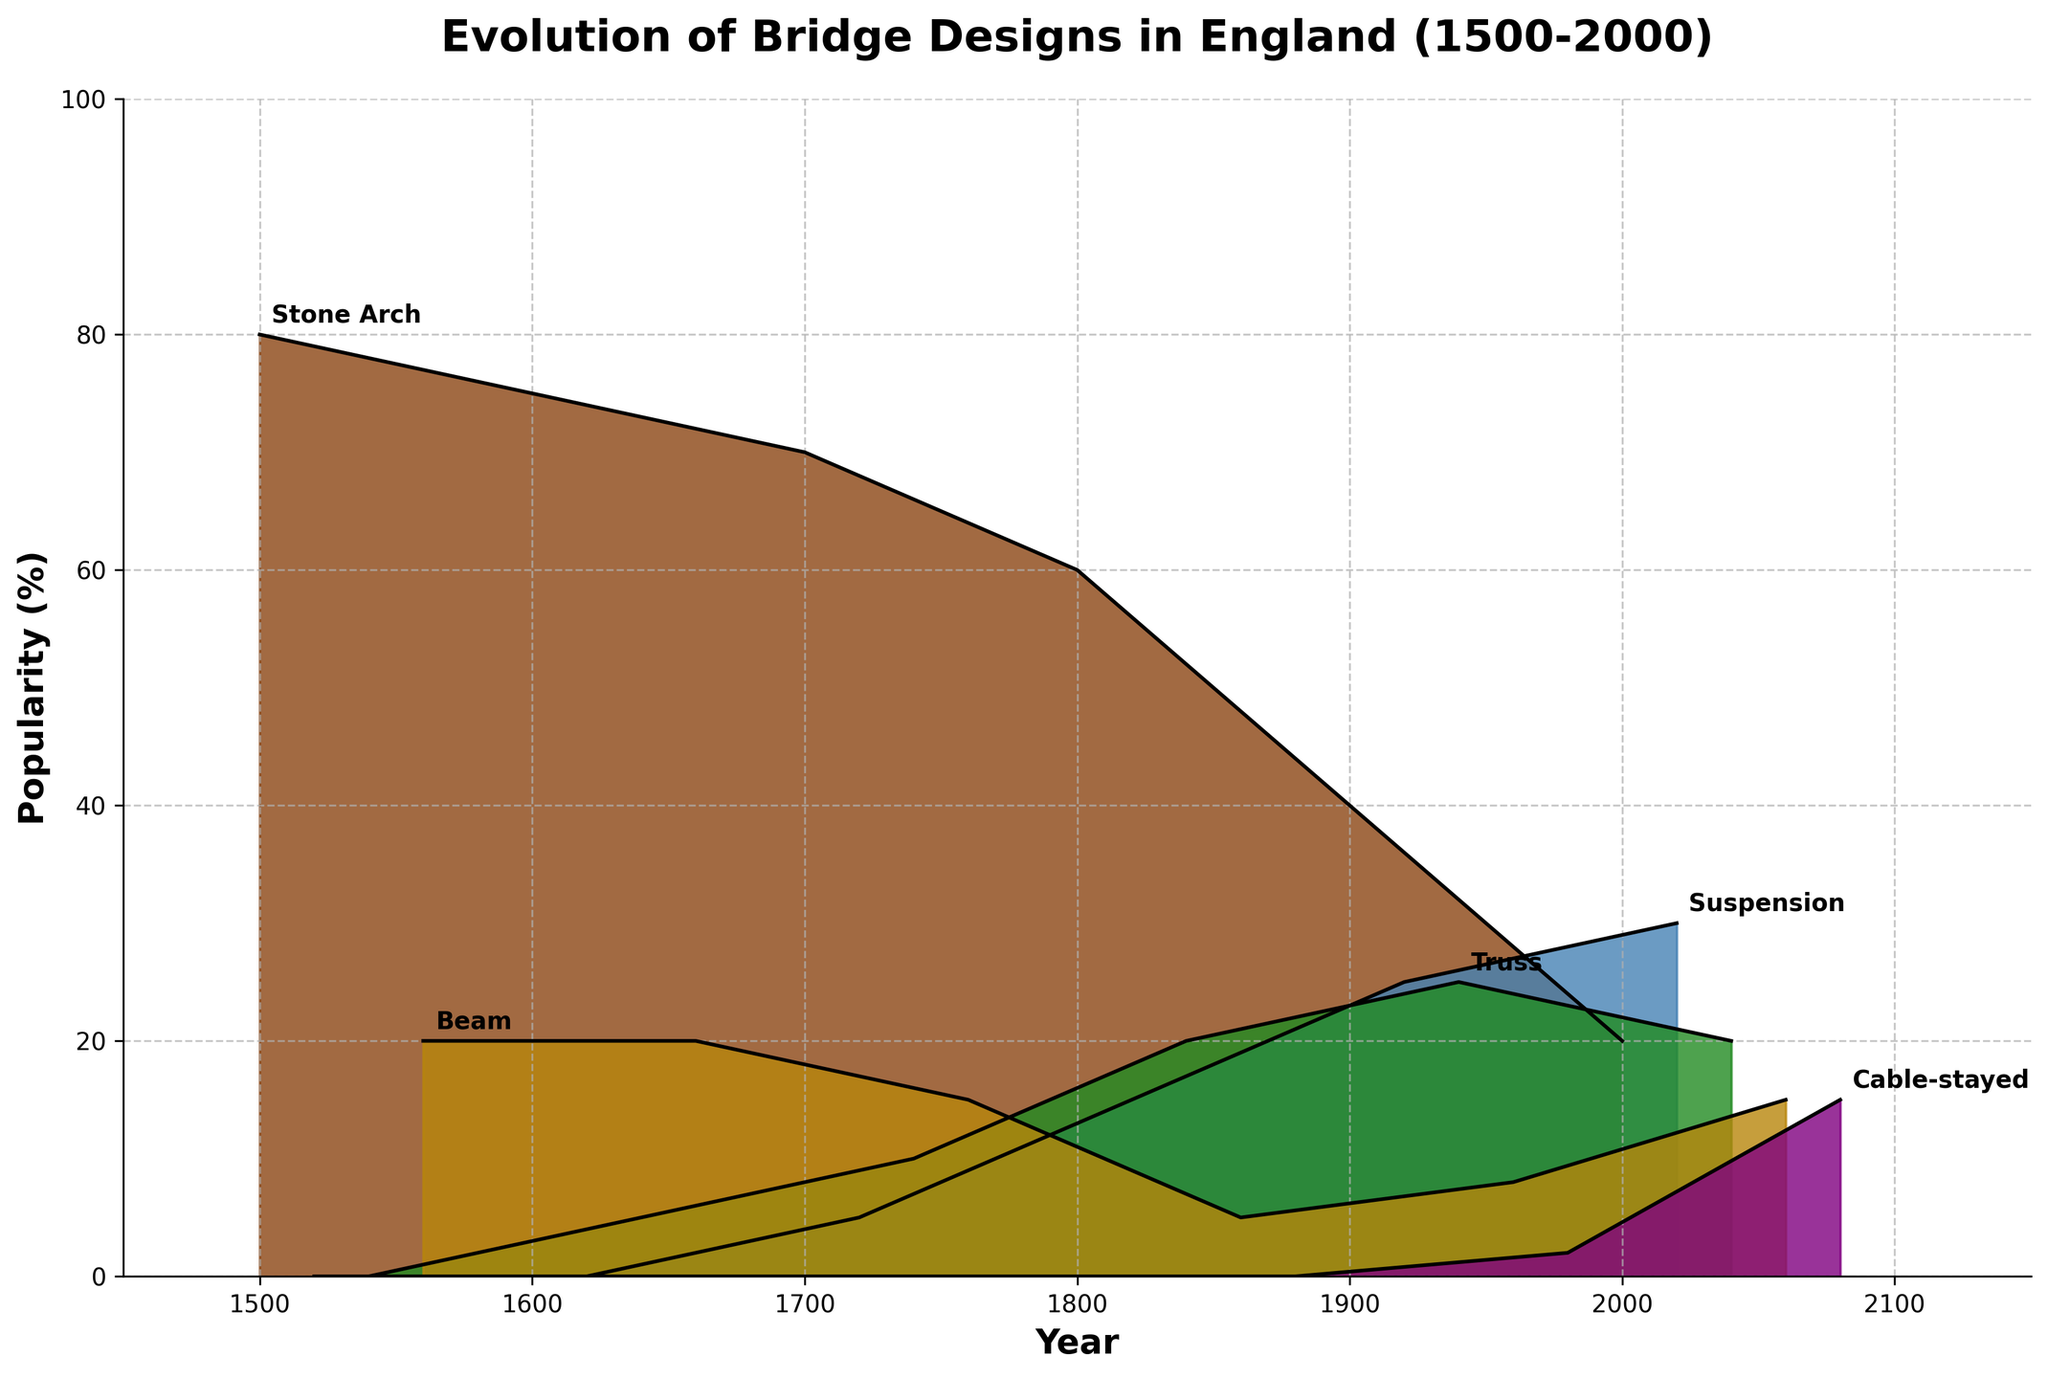Which bridge design was the most popular in the year 1500? By examining the plot for the year 1500, the highest point on the corresponding line is for the Stone Arch bridge design, indicating its popularity at 80%.
Answer: Stone Arch What is the trend for the popularity of Stone Arch bridges from 1500 to 2000? Observing the Stone Arch line across the years from 1500 to 2000, it's clear that the popularity consistently decreases from 80% in 1500 to 20% in 2000.
Answer: Decreasing During which century did Suspension bridges first become popular according to the plot? By looking at the plot lines for the Suspension bridge, it appears first in the 1700s, shown by a small rise in that time period.
Answer: 1700s Which bridge type shows the most significant increase in popularity from 1500 to 2000? Comparing the endpoints of each bridge type across the years, Cable-stayed bridges have the steepest rise, going from 0% to 15% popularity from 1500 to 2000.
Answer: Cable-stayed At what year do all five bridge types appear together on the plot? Observing the timeline, all five bridge types (including Cable-stayed bridges) are plotted around the year 2000.
Answer: 2000 What is the combined popularity of Suspension and Truss bridges in the year 1800? Suspension bridges are at 15% and Truss bridges are at 20% in 1800 according to the plot, adding them together gives: 15% + 20% = 35%.
Answer: 35% By how much did the popularity of Beam bridges change between 1500 and 1900? The popularity of Beam bridges was 20% in 1500 and 8% in 1900, showing a decrease of 20% - 8% = 12%.
Answer: 12% Which bridge design shows the steepest decline in popularity from its peak to the year 2000? Analyzing each line for the highest point and its endpoint, Stone Arch bridges decline from 80% to 20%, a drop of 60%, the steepest among all designs.
Answer: Stone Arch Which bridge design maintained a relatively stable popularity throughout the centuries? By examining the consistency of the plot lines, Truss bridges show the most stable popularity, with fluctuations relatively minor compared to others.
Answer: Truss 